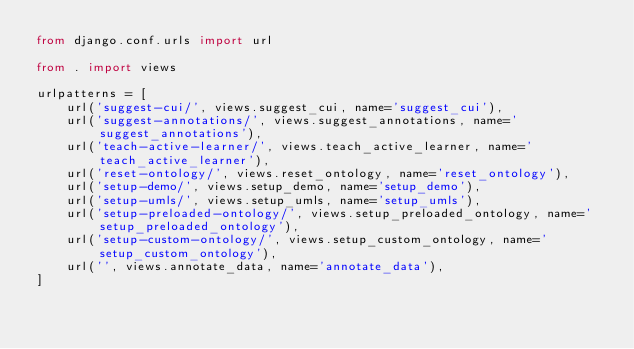Convert code to text. <code><loc_0><loc_0><loc_500><loc_500><_Python_>from django.conf.urls import url

from . import views

urlpatterns = [
    url('suggest-cui/', views.suggest_cui, name='suggest_cui'),
    url('suggest-annotations/', views.suggest_annotations, name='suggest_annotations'),
    url('teach-active-learner/', views.teach_active_learner, name='teach_active_learner'),
    url('reset-ontology/', views.reset_ontology, name='reset_ontology'),
    url('setup-demo/', views.setup_demo, name='setup_demo'),
    url('setup-umls/', views.setup_umls, name='setup_umls'),
    url('setup-preloaded-ontology/', views.setup_preloaded_ontology, name='setup_preloaded_ontology'),
    url('setup-custom-ontology/', views.setup_custom_ontology, name='setup_custom_ontology'),
    url('', views.annotate_data, name='annotate_data'),
]
</code> 